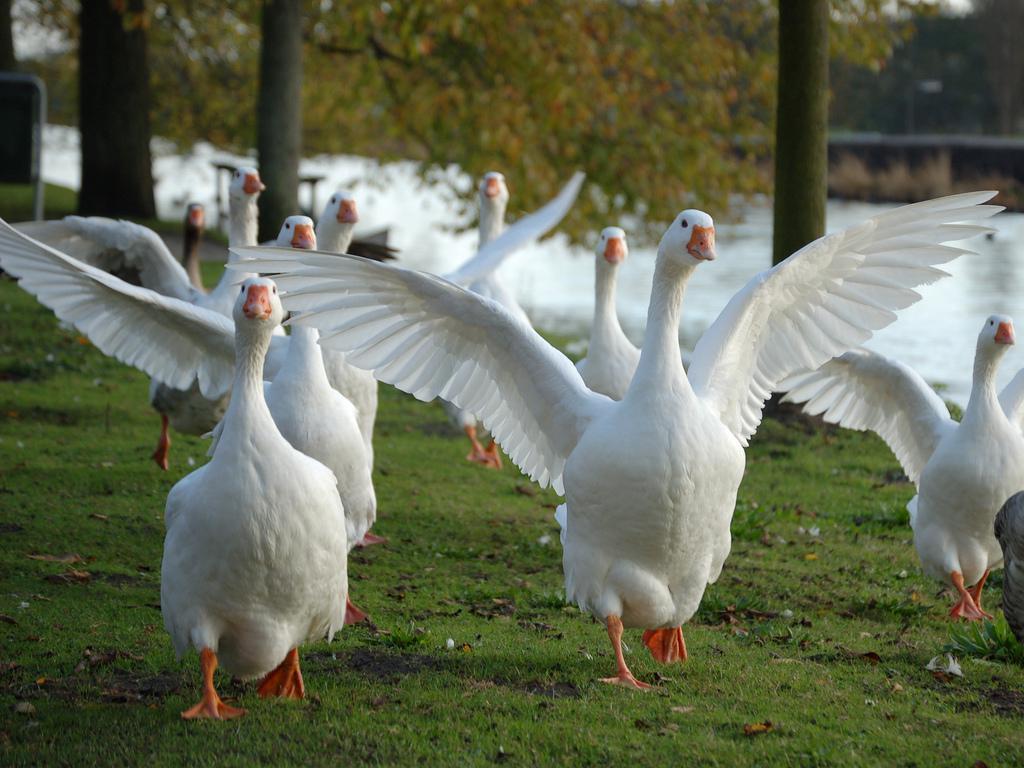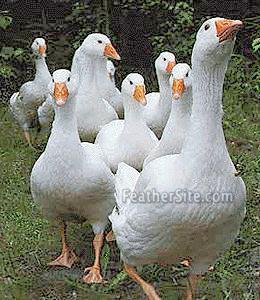The first image is the image on the left, the second image is the image on the right. Examine the images to the left and right. Is the description "There is a single goose in the right image." accurate? Answer yes or no. No. The first image is the image on the left, the second image is the image on the right. For the images shown, is this caption "There are more than ten geese in the images." true? Answer yes or no. Yes. 